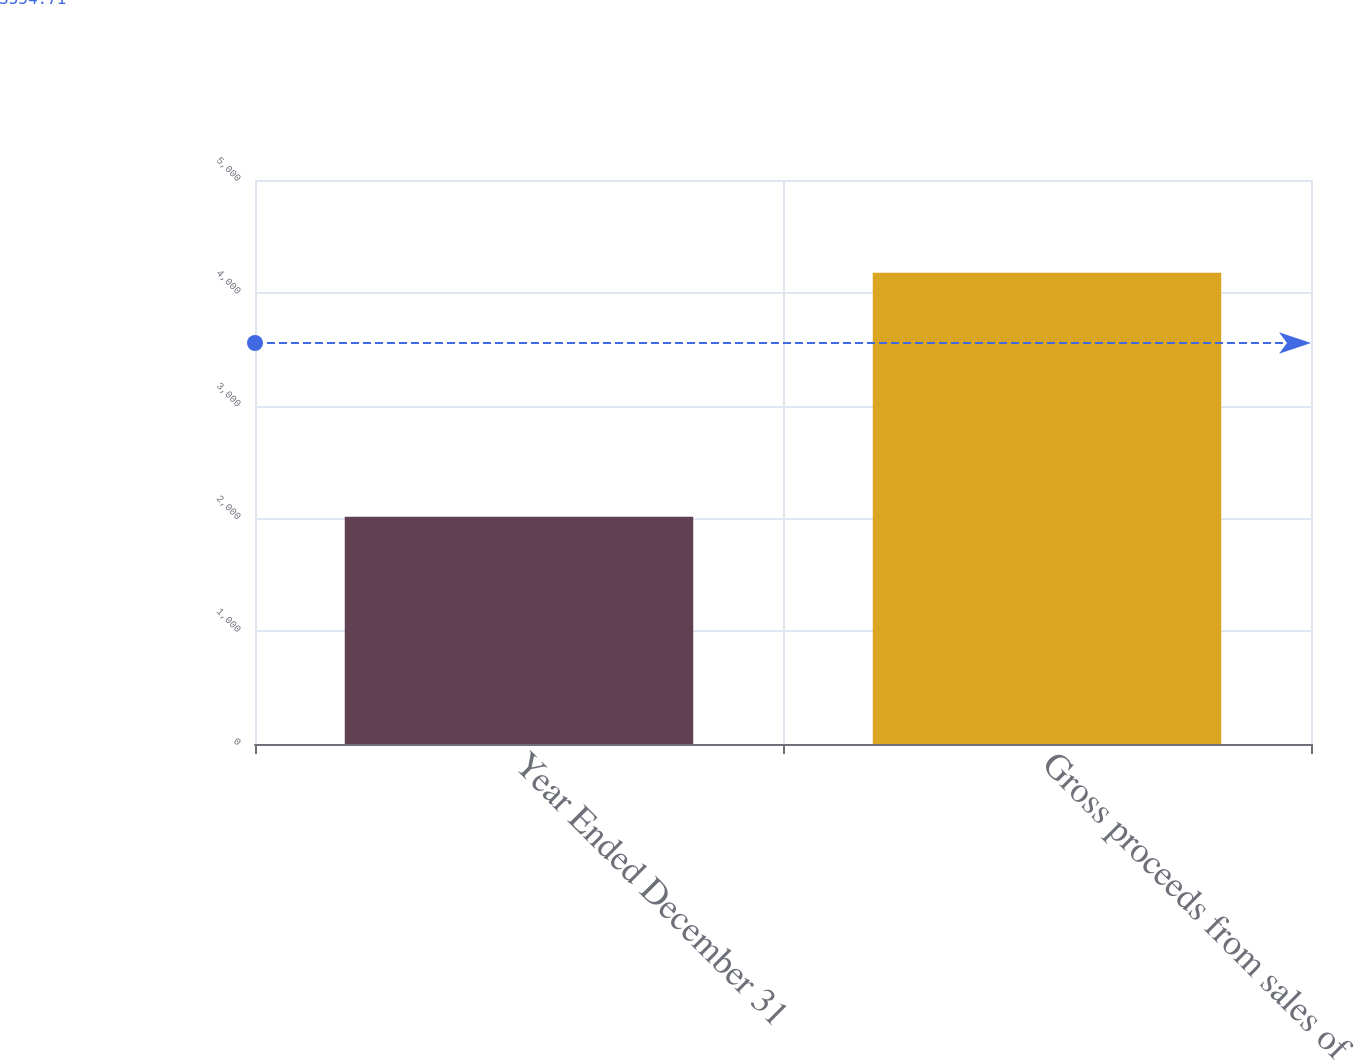<chart> <loc_0><loc_0><loc_500><loc_500><bar_chart><fcel>Year Ended December 31<fcel>Gross proceeds from sales of<nl><fcel>2015<fcel>4177<nl></chart> 